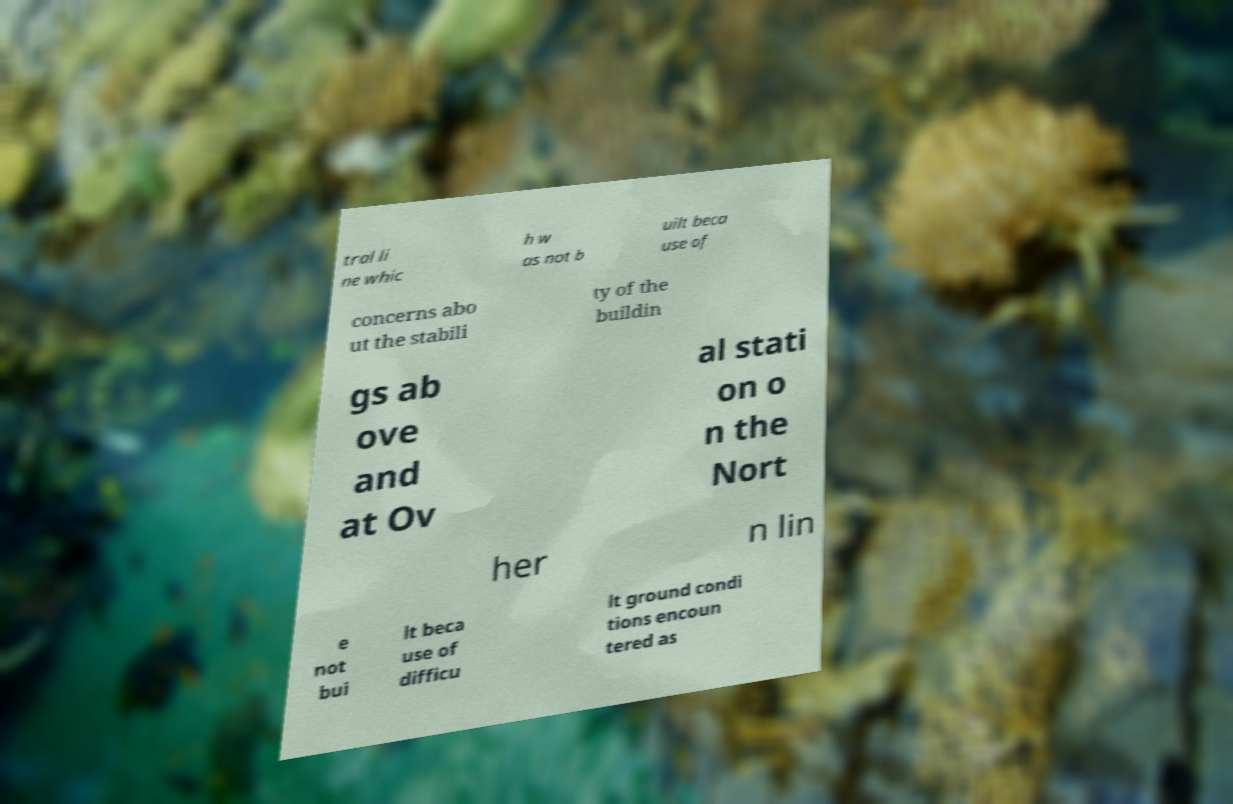For documentation purposes, I need the text within this image transcribed. Could you provide that? tral li ne whic h w as not b uilt beca use of concerns abo ut the stabili ty of the buildin gs ab ove and at Ov al stati on o n the Nort her n lin e not bui lt beca use of difficu lt ground condi tions encoun tered as 